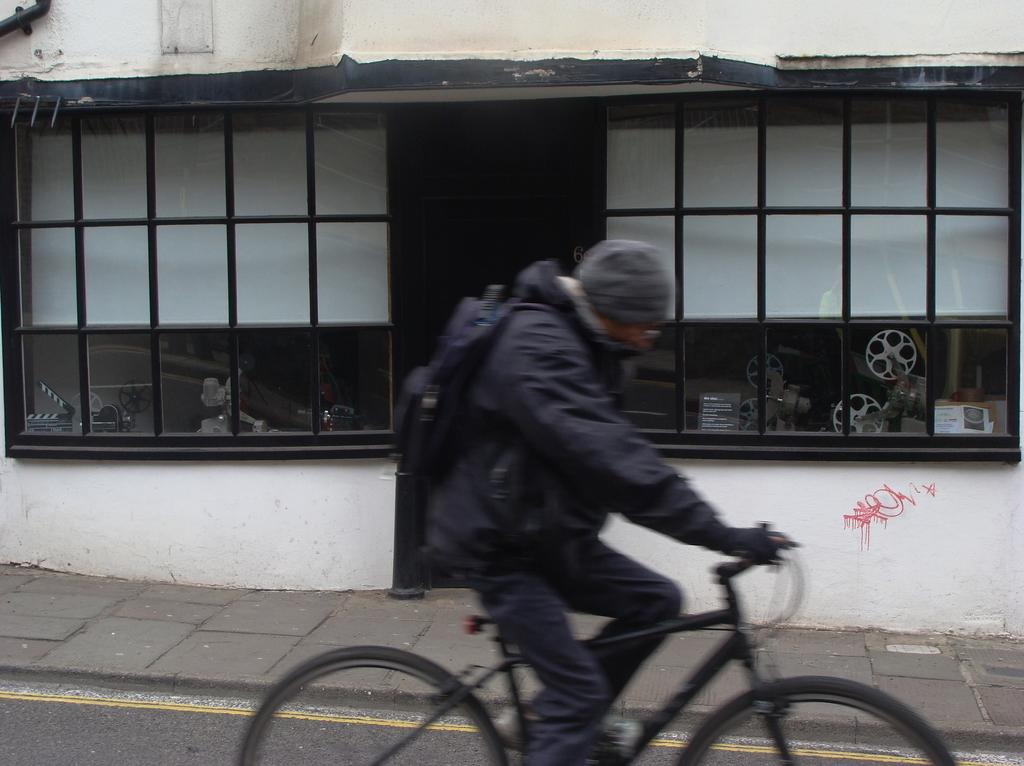What is the main feature of the image? There is a road in the image. What activity is taking place on the road? A man is riding a bicycle on the road. What can be seen in the background of the image? There is a glass wall and black color rods in the background of the image. What type of jail can be seen in the image? There is no jail present in the image. What is the man's interest in riding the bicycle in the image? The image does not provide information about the man's interest in riding the bicycle. 